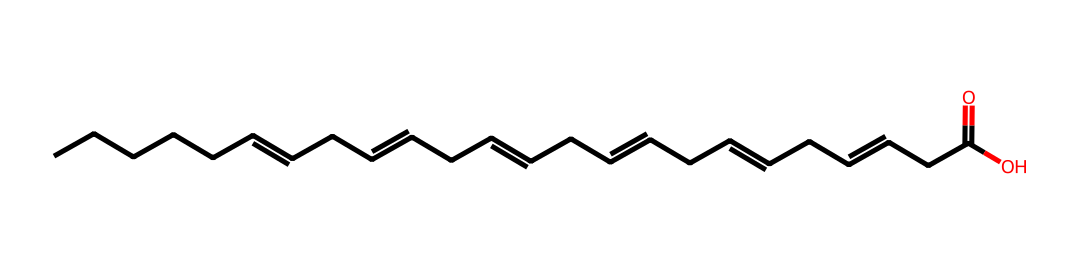What is the general category of this chemical? This chemical has long carbon chains and multiple double bonds typical of fatty acids, especially omega-3. These features signify it belongs to the lipid category.
Answer: lipid How many carbon atoms are in this omega-3 fatty acid? To determine the number of carbon atoms, count the "C" atoms in the SMILES representation. There are 18 carbon atoms.
Answer: 18 What is the type of bond found between carbon atoms in this structure? The chemical structure features multiple double bonds (indicated by "="), showing the presence of unsaturation in the hydrocarbon chains. These double bonds are characteristic of olefinic bonds found in unsaturated fatty acids.
Answer: double bonds How many double bonds does this omega-3 fatty acid have? By analyzing the structure in the SMILES, the double bonds are represented by the "=" signs. There are 6 double bonds present in the chain.
Answer: 6 What functional group is present at the end of this fatty acid? The structure ends with "C(=O)O" which signifies a carboxylic acid functional group. This group is characteristic of fatty acids, linking to their classification.
Answer: carboxylic acid What is the characteristic feature of omega-3 fatty acids based on the structure? The presence of multiple double bonds and specifically the positioning of the first double bond at the third carbon from the end of the molecule (counting from the methyl end) is indicative of omega-3 fatty acids.
Answer: three double bonds 